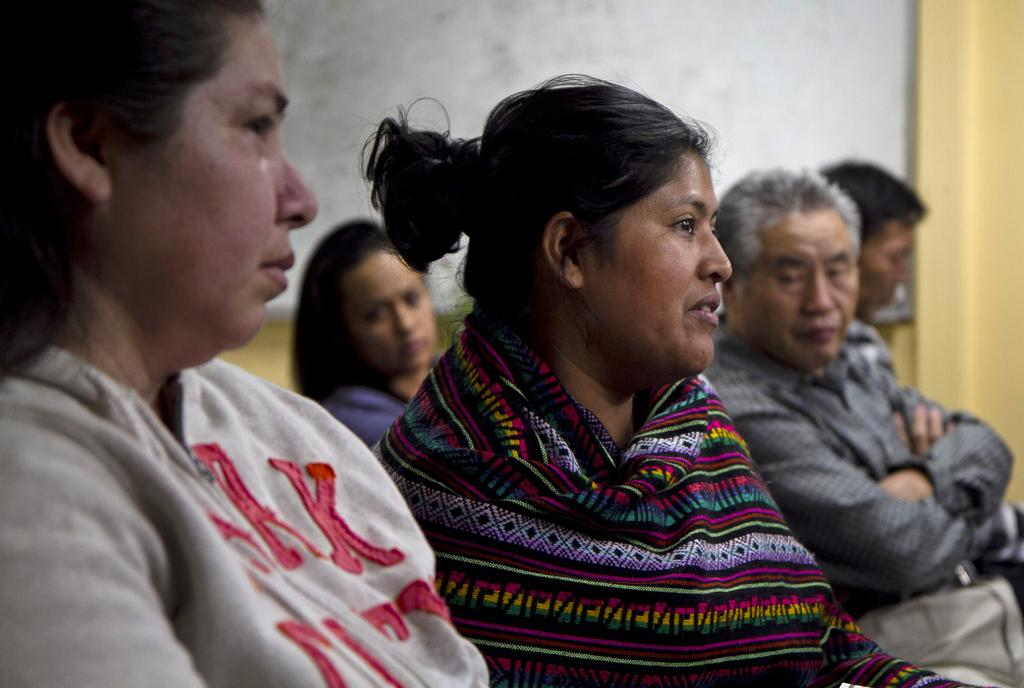Where was the image taken? The image was taken in a room. What are the people in the room doing? The people in the room are sitting. Can you describe the background of the image? The background of the image is blurred, and there is a wall visible. What type of foot is visible on the wall in the image? There is no foot visible on the wall in the image. Is there a crown on the head of any person in the image? There is no crown visible on the head of any person in the image. 